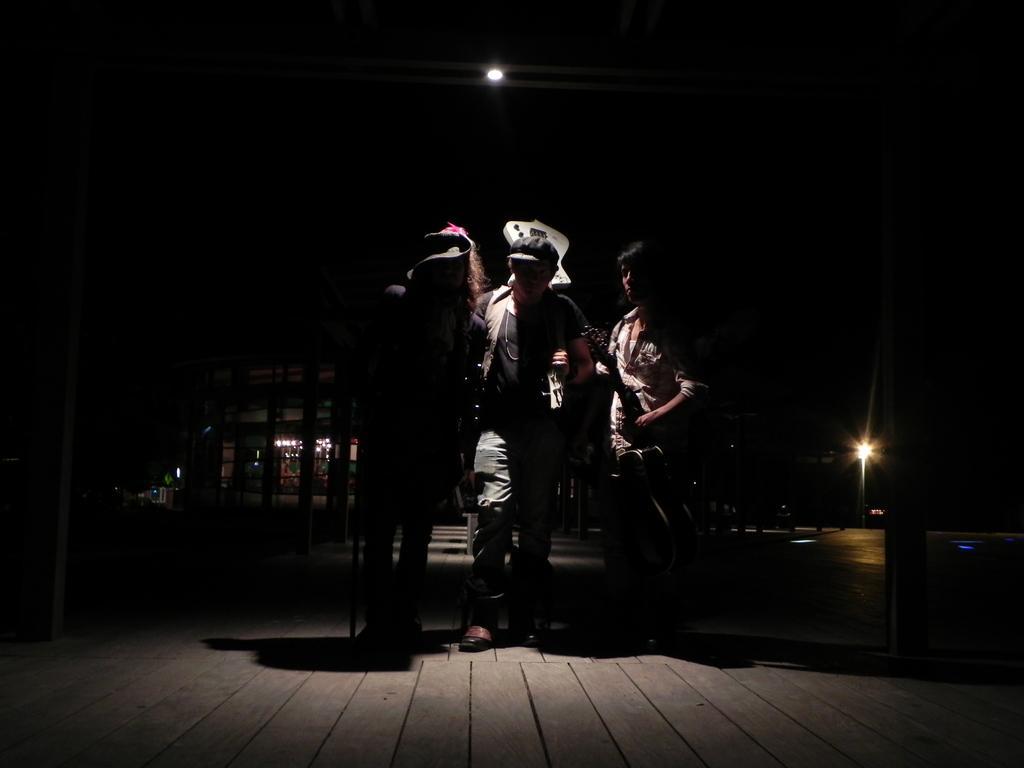Could you give a brief overview of what you see in this image? This is a dark picture, we can see three persons standing on the wooden floor. 